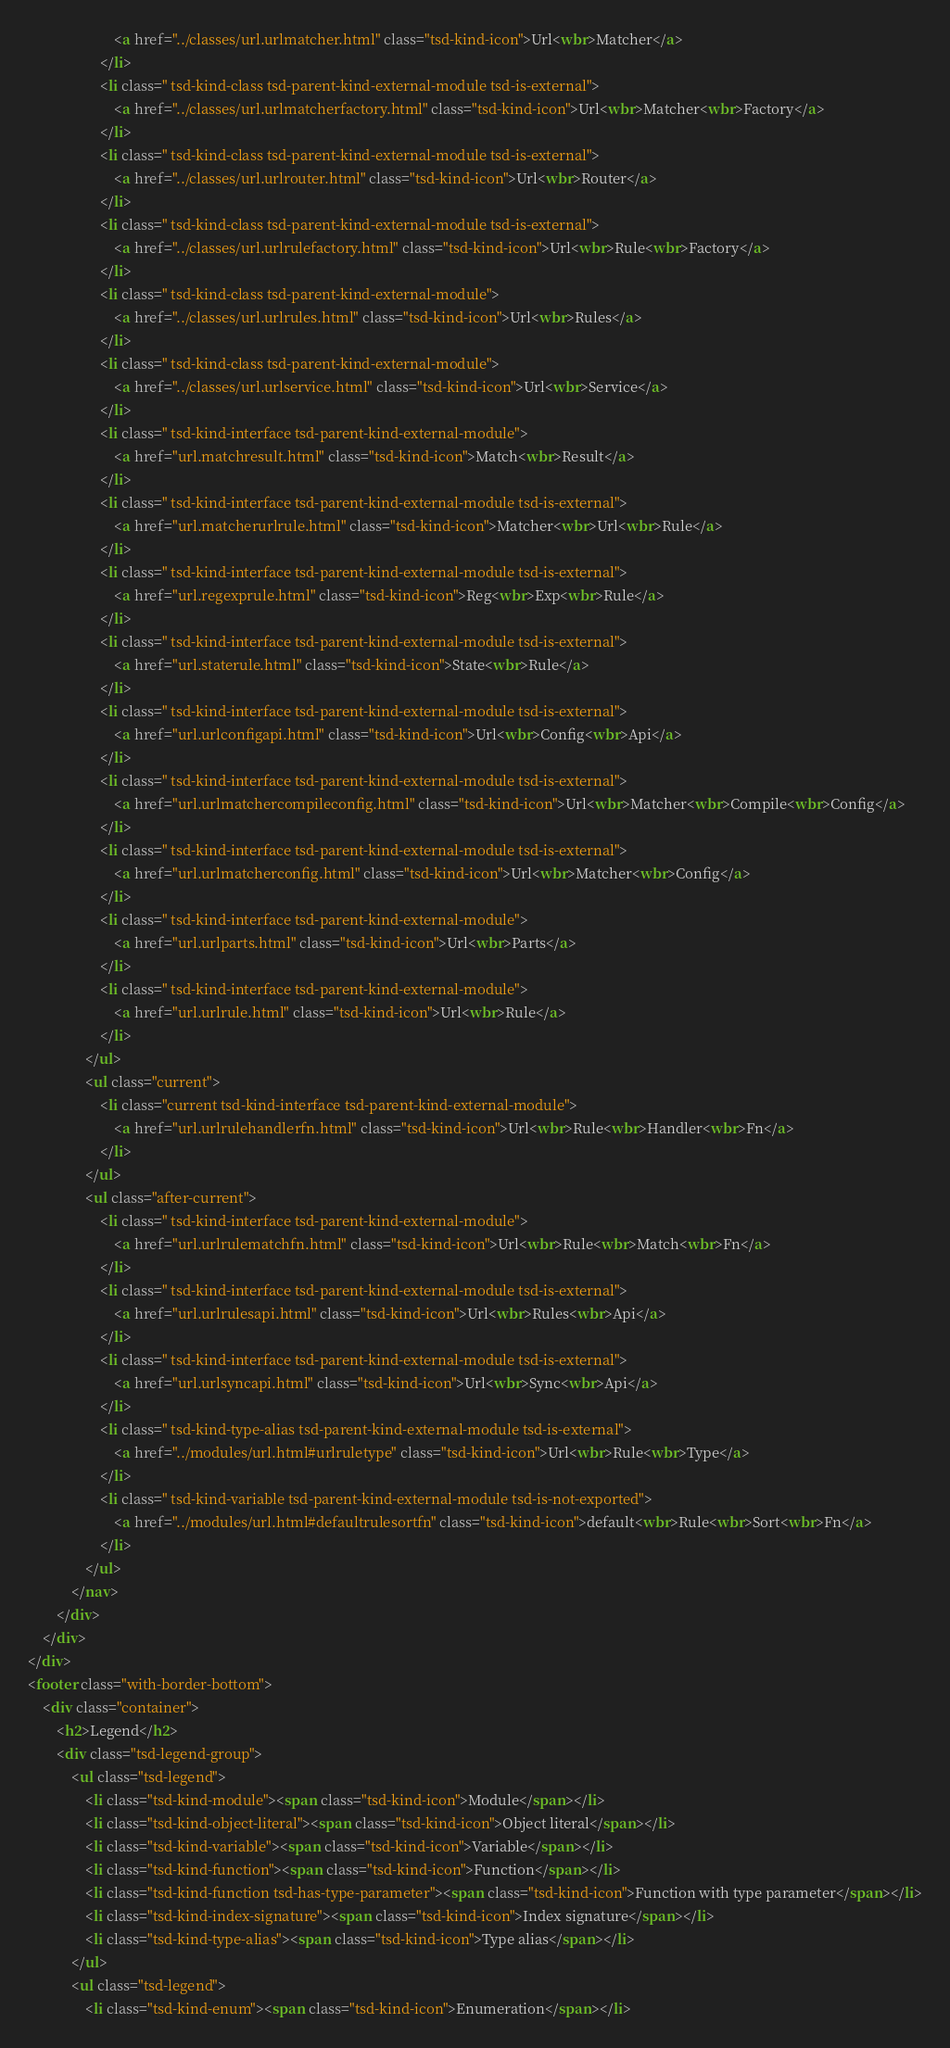Convert code to text. <code><loc_0><loc_0><loc_500><loc_500><_HTML_>						<a href="../classes/url.urlmatcher.html" class="tsd-kind-icon">Url<wbr>Matcher</a>
					</li>
					<li class=" tsd-kind-class tsd-parent-kind-external-module tsd-is-external">
						<a href="../classes/url.urlmatcherfactory.html" class="tsd-kind-icon">Url<wbr>Matcher<wbr>Factory</a>
					</li>
					<li class=" tsd-kind-class tsd-parent-kind-external-module tsd-is-external">
						<a href="../classes/url.urlrouter.html" class="tsd-kind-icon">Url<wbr>Router</a>
					</li>
					<li class=" tsd-kind-class tsd-parent-kind-external-module tsd-is-external">
						<a href="../classes/url.urlrulefactory.html" class="tsd-kind-icon">Url<wbr>Rule<wbr>Factory</a>
					</li>
					<li class=" tsd-kind-class tsd-parent-kind-external-module">
						<a href="../classes/url.urlrules.html" class="tsd-kind-icon">Url<wbr>Rules</a>
					</li>
					<li class=" tsd-kind-class tsd-parent-kind-external-module">
						<a href="../classes/url.urlservice.html" class="tsd-kind-icon">Url<wbr>Service</a>
					</li>
					<li class=" tsd-kind-interface tsd-parent-kind-external-module">
						<a href="url.matchresult.html" class="tsd-kind-icon">Match<wbr>Result</a>
					</li>
					<li class=" tsd-kind-interface tsd-parent-kind-external-module tsd-is-external">
						<a href="url.matcherurlrule.html" class="tsd-kind-icon">Matcher<wbr>Url<wbr>Rule</a>
					</li>
					<li class=" tsd-kind-interface tsd-parent-kind-external-module tsd-is-external">
						<a href="url.regexprule.html" class="tsd-kind-icon">Reg<wbr>Exp<wbr>Rule</a>
					</li>
					<li class=" tsd-kind-interface tsd-parent-kind-external-module tsd-is-external">
						<a href="url.staterule.html" class="tsd-kind-icon">State<wbr>Rule</a>
					</li>
					<li class=" tsd-kind-interface tsd-parent-kind-external-module tsd-is-external">
						<a href="url.urlconfigapi.html" class="tsd-kind-icon">Url<wbr>Config<wbr>Api</a>
					</li>
					<li class=" tsd-kind-interface tsd-parent-kind-external-module tsd-is-external">
						<a href="url.urlmatchercompileconfig.html" class="tsd-kind-icon">Url<wbr>Matcher<wbr>Compile<wbr>Config</a>
					</li>
					<li class=" tsd-kind-interface tsd-parent-kind-external-module tsd-is-external">
						<a href="url.urlmatcherconfig.html" class="tsd-kind-icon">Url<wbr>Matcher<wbr>Config</a>
					</li>
					<li class=" tsd-kind-interface tsd-parent-kind-external-module">
						<a href="url.urlparts.html" class="tsd-kind-icon">Url<wbr>Parts</a>
					</li>
					<li class=" tsd-kind-interface tsd-parent-kind-external-module">
						<a href="url.urlrule.html" class="tsd-kind-icon">Url<wbr>Rule</a>
					</li>
				</ul>
				<ul class="current">
					<li class="current tsd-kind-interface tsd-parent-kind-external-module">
						<a href="url.urlrulehandlerfn.html" class="tsd-kind-icon">Url<wbr>Rule<wbr>Handler<wbr>Fn</a>
					</li>
				</ul>
				<ul class="after-current">
					<li class=" tsd-kind-interface tsd-parent-kind-external-module">
						<a href="url.urlrulematchfn.html" class="tsd-kind-icon">Url<wbr>Rule<wbr>Match<wbr>Fn</a>
					</li>
					<li class=" tsd-kind-interface tsd-parent-kind-external-module tsd-is-external">
						<a href="url.urlrulesapi.html" class="tsd-kind-icon">Url<wbr>Rules<wbr>Api</a>
					</li>
					<li class=" tsd-kind-interface tsd-parent-kind-external-module tsd-is-external">
						<a href="url.urlsyncapi.html" class="tsd-kind-icon">Url<wbr>Sync<wbr>Api</a>
					</li>
					<li class=" tsd-kind-type-alias tsd-parent-kind-external-module tsd-is-external">
						<a href="../modules/url.html#urlruletype" class="tsd-kind-icon">Url<wbr>Rule<wbr>Type</a>
					</li>
					<li class=" tsd-kind-variable tsd-parent-kind-external-module tsd-is-not-exported">
						<a href="../modules/url.html#defaultrulesortfn" class="tsd-kind-icon">default<wbr>Rule<wbr>Sort<wbr>Fn</a>
					</li>
				</ul>
			</nav>
		</div>
	</div>
</div>
<footer class="with-border-bottom">
	<div class="container">
		<h2>Legend</h2>
		<div class="tsd-legend-group">
			<ul class="tsd-legend">
				<li class="tsd-kind-module"><span class="tsd-kind-icon">Module</span></li>
				<li class="tsd-kind-object-literal"><span class="tsd-kind-icon">Object literal</span></li>
				<li class="tsd-kind-variable"><span class="tsd-kind-icon">Variable</span></li>
				<li class="tsd-kind-function"><span class="tsd-kind-icon">Function</span></li>
				<li class="tsd-kind-function tsd-has-type-parameter"><span class="tsd-kind-icon">Function with type parameter</span></li>
				<li class="tsd-kind-index-signature"><span class="tsd-kind-icon">Index signature</span></li>
				<li class="tsd-kind-type-alias"><span class="tsd-kind-icon">Type alias</span></li>
			</ul>
			<ul class="tsd-legend">
				<li class="tsd-kind-enum"><span class="tsd-kind-icon">Enumeration</span></li></code> 